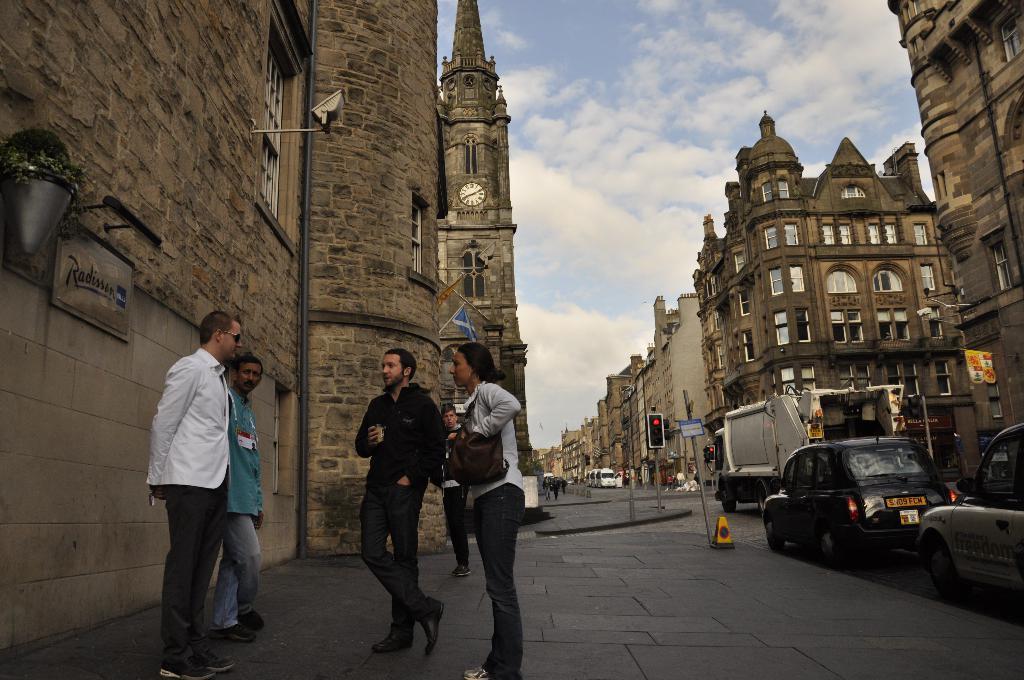Describe this image in one or two sentences. In this image, we can see few people are standing on the walkway. Here a woman is wearing a bag and a man is holding some object. Background we can see buildings, walls, plants, flag, banner, traffic signal, windows, poles, road and vehicles. Here we can see the cloudy sky. In the middle we can see a clock on the wall. 